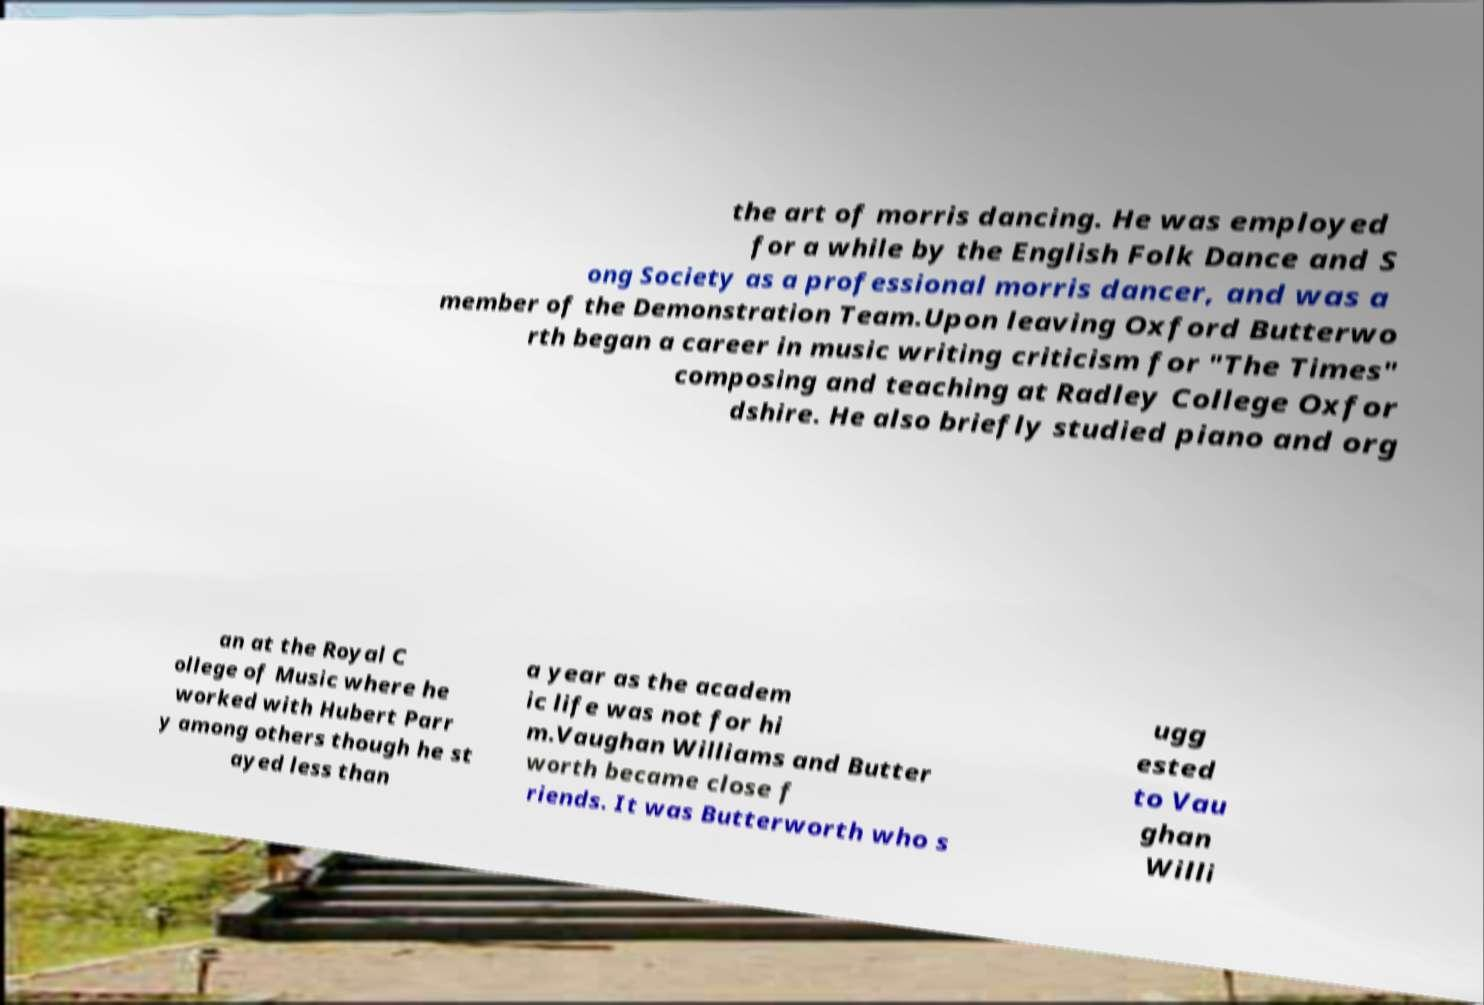Please identify and transcribe the text found in this image. the art of morris dancing. He was employed for a while by the English Folk Dance and S ong Society as a professional morris dancer, and was a member of the Demonstration Team.Upon leaving Oxford Butterwo rth began a career in music writing criticism for "The Times" composing and teaching at Radley College Oxfor dshire. He also briefly studied piano and org an at the Royal C ollege of Music where he worked with Hubert Parr y among others though he st ayed less than a year as the academ ic life was not for hi m.Vaughan Williams and Butter worth became close f riends. It was Butterworth who s ugg ested to Vau ghan Willi 